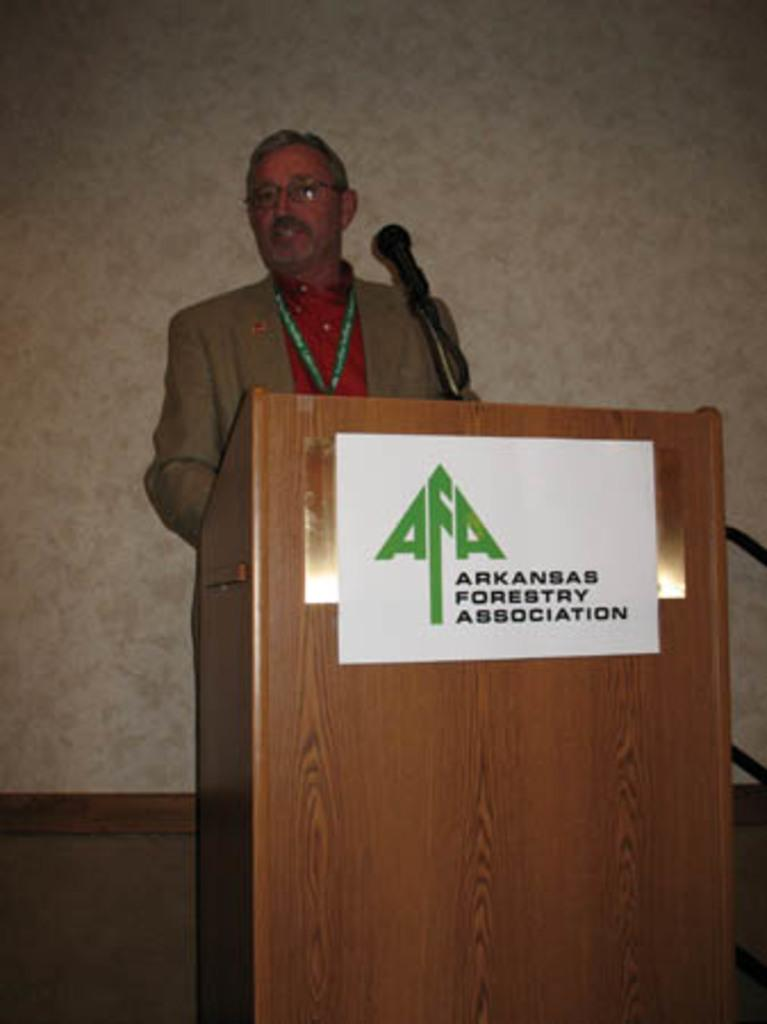What is present in the image that people typically use for eating or working? A: There is a table in the image. What is the person in the image doing in relation to the table? A person is standing in front of the table. What is the person doing while standing in front of the table? The person is speaking. What is attached to the table in the image? There is a poster attached to the table. What can be seen in the background of the image? There is a wall in the background of the image. How does the person's hair contribute to the growth of the plants in the image? There are no plants present in the image, and the person's hair is not shown to have any effect on plant growth. 